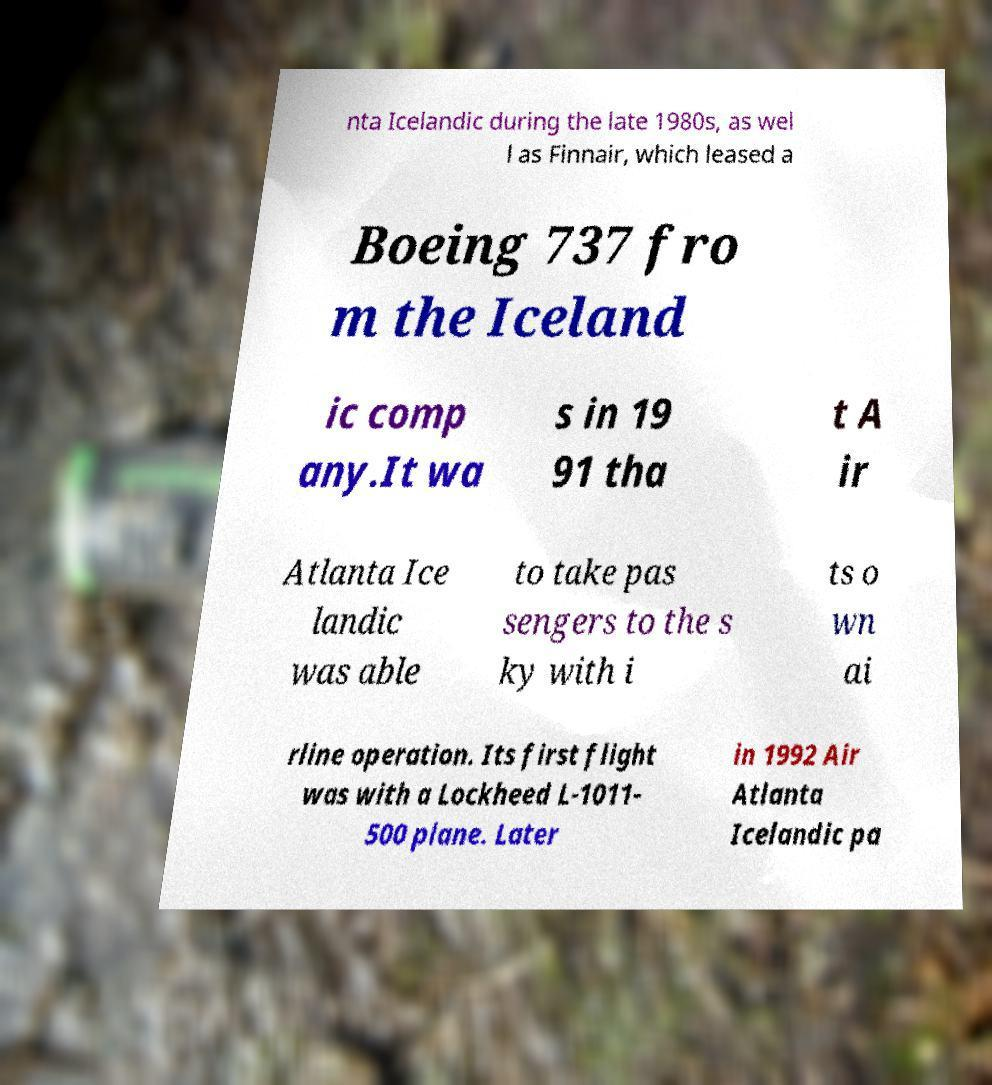What messages or text are displayed in this image? I need them in a readable, typed format. nta Icelandic during the late 1980s, as wel l as Finnair, which leased a Boeing 737 fro m the Iceland ic comp any.It wa s in 19 91 tha t A ir Atlanta Ice landic was able to take pas sengers to the s ky with i ts o wn ai rline operation. Its first flight was with a Lockheed L-1011- 500 plane. Later in 1992 Air Atlanta Icelandic pa 